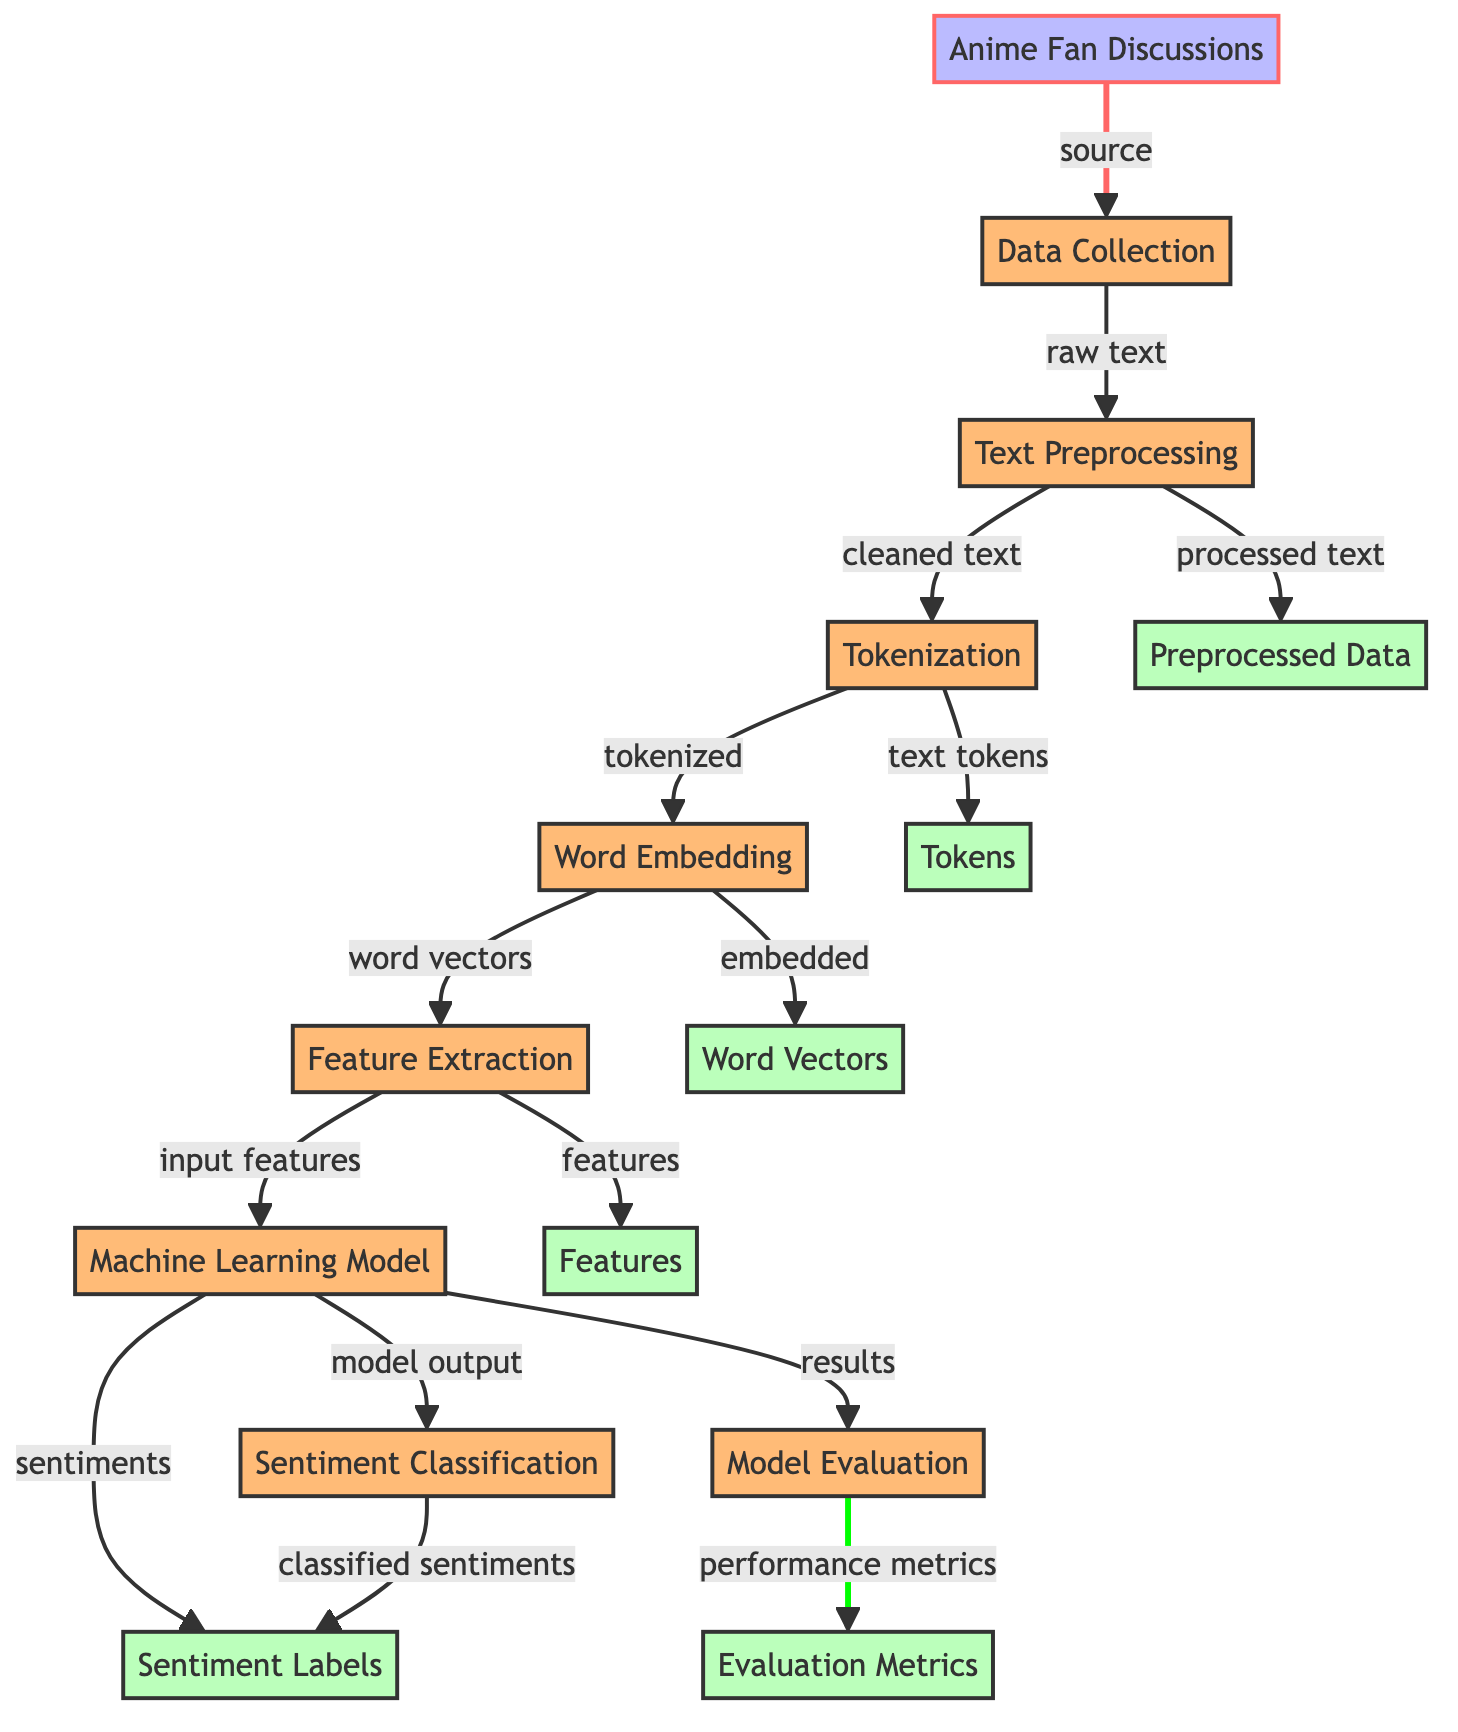What is the first process in the diagram? The first process node after "Anime Fan Discussions" is "Data Collection," which directly follows the input node.
Answer: Data Collection How many output nodes are there in the diagram? The diagram contains five output nodes: "Preprocessed Data," "Tokens," "Word Vectors," "Features," and "Sentiment Labels," which can be counted from the output section.
Answer: 5 Which node directly follows "Word Embedding"? The "Feature Extraction" node directly follows "Word Embedding" as per the flow of the diagram, indicating that features are extracted after obtaining word vectors.
Answer: Feature Extraction What is the relationship between "Machine Learning Model" and "Sentiment Classification"? "Machine Learning Model" output feeds into "Sentiment Classification," meaning that the sentiments produced by the model are classified in this subsequent step.
Answer: Machine Learning Model feeds into Sentiment Classification What is the final output of the model evaluation process? The last process node "Model Evaluation" leads to the output node "Evaluation Metrics," indicating that performance metrics are generated after the evaluation process.
Answer: Evaluation Metrics What type of sentiment analysis is being conducted in this diagram? The diagram focuses on "Sentiment Analysis of Existential Themes in Anime Fan Discussions," as specified in the context of the process.
Answer: Sentiment Analysis of Existential Themes What data transitions from "Text Preprocessing" to "Tokens"? The transition from "Text Preprocessing" results in "text tokens," which indicates that preprocessed text is then tokenized in the process flow.
Answer: text tokens Which output is produced after "Word Embedding"? "Word Vectors" are produced as output after "Word Embedding," showing the transformation of embedded words into vector representations.
Answer: Word Vectors 